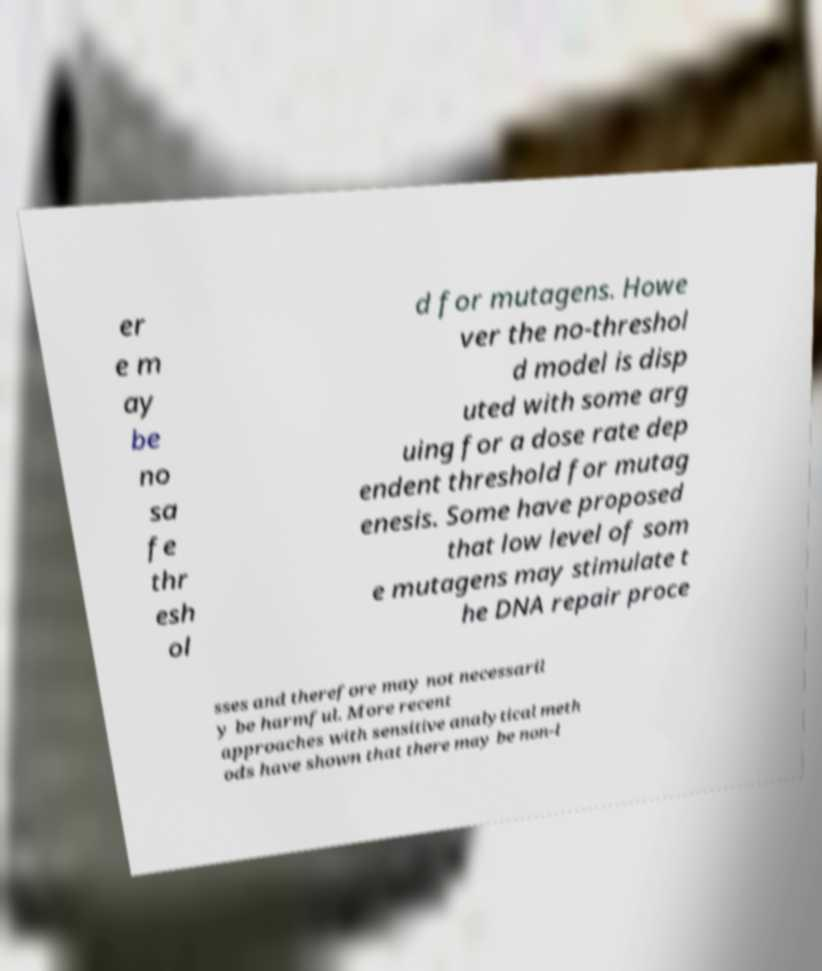What messages or text are displayed in this image? I need them in a readable, typed format. er e m ay be no sa fe thr esh ol d for mutagens. Howe ver the no-threshol d model is disp uted with some arg uing for a dose rate dep endent threshold for mutag enesis. Some have proposed that low level of som e mutagens may stimulate t he DNA repair proce sses and therefore may not necessaril y be harmful. More recent approaches with sensitive analytical meth ods have shown that there may be non-l 